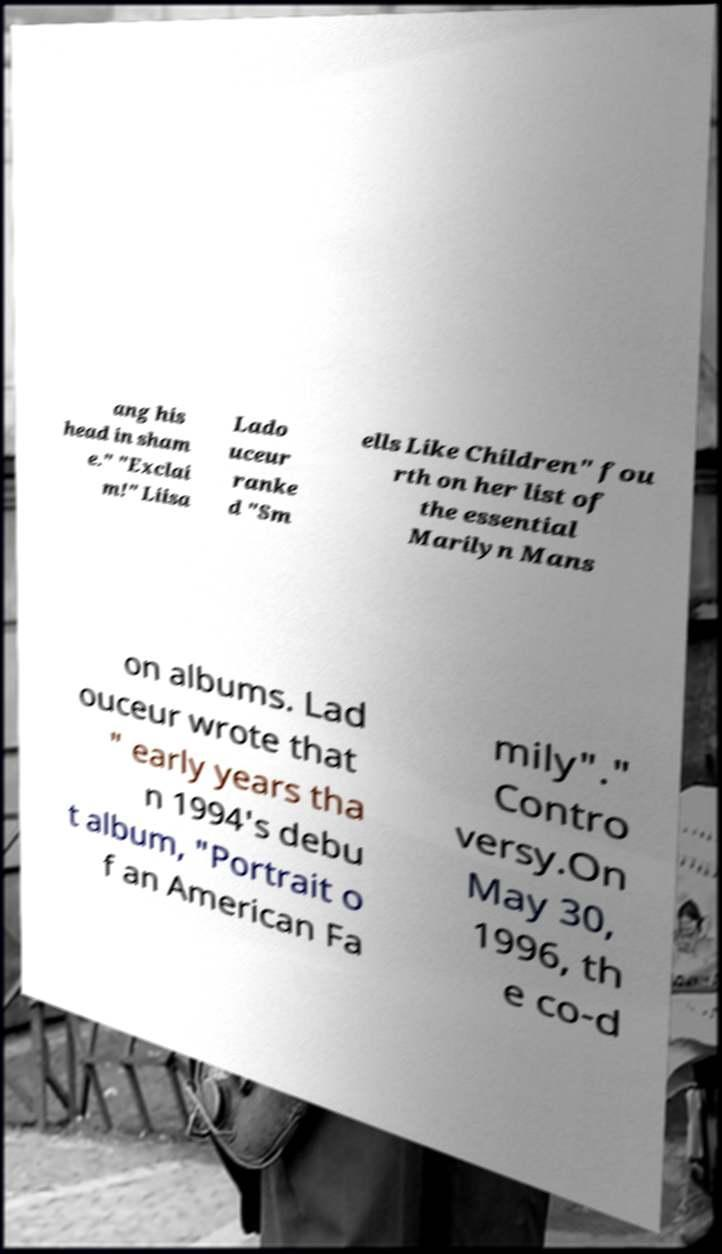Can you read and provide the text displayed in the image?This photo seems to have some interesting text. Can you extract and type it out for me? ang his head in sham e." "Exclai m!" Liisa Lado uceur ranke d "Sm ells Like Children" fou rth on her list of the essential Marilyn Mans on albums. Lad ouceur wrote that " early years tha n 1994's debu t album, "Portrait o f an American Fa mily"." Contro versy.On May 30, 1996, th e co-d 